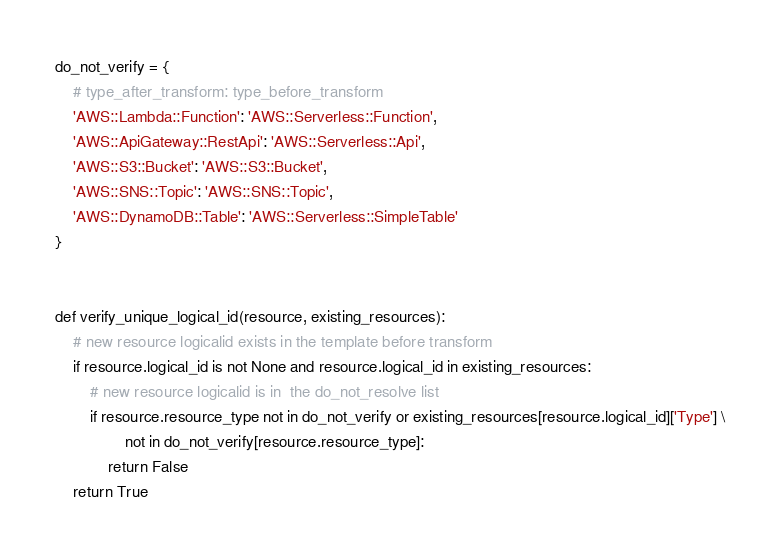<code> <loc_0><loc_0><loc_500><loc_500><_Python_>do_not_verify = {
    # type_after_transform: type_before_transform
    'AWS::Lambda::Function': 'AWS::Serverless::Function',
    'AWS::ApiGateway::RestApi': 'AWS::Serverless::Api',
    'AWS::S3::Bucket': 'AWS::S3::Bucket',
    'AWS::SNS::Topic': 'AWS::SNS::Topic',
    'AWS::DynamoDB::Table': 'AWS::Serverless::SimpleTable'
}


def verify_unique_logical_id(resource, existing_resources):
    # new resource logicalid exists in the template before transform
    if resource.logical_id is not None and resource.logical_id in existing_resources:
        # new resource logicalid is in  the do_not_resolve list
        if resource.resource_type not in do_not_verify or existing_resources[resource.logical_id]['Type'] \
                not in do_not_verify[resource.resource_type]:
            return False
    return True
</code> 